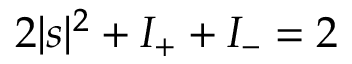Convert formula to latex. <formula><loc_0><loc_0><loc_500><loc_500>2 | s | ^ { 2 } + I _ { + } + I _ { - } = 2</formula> 